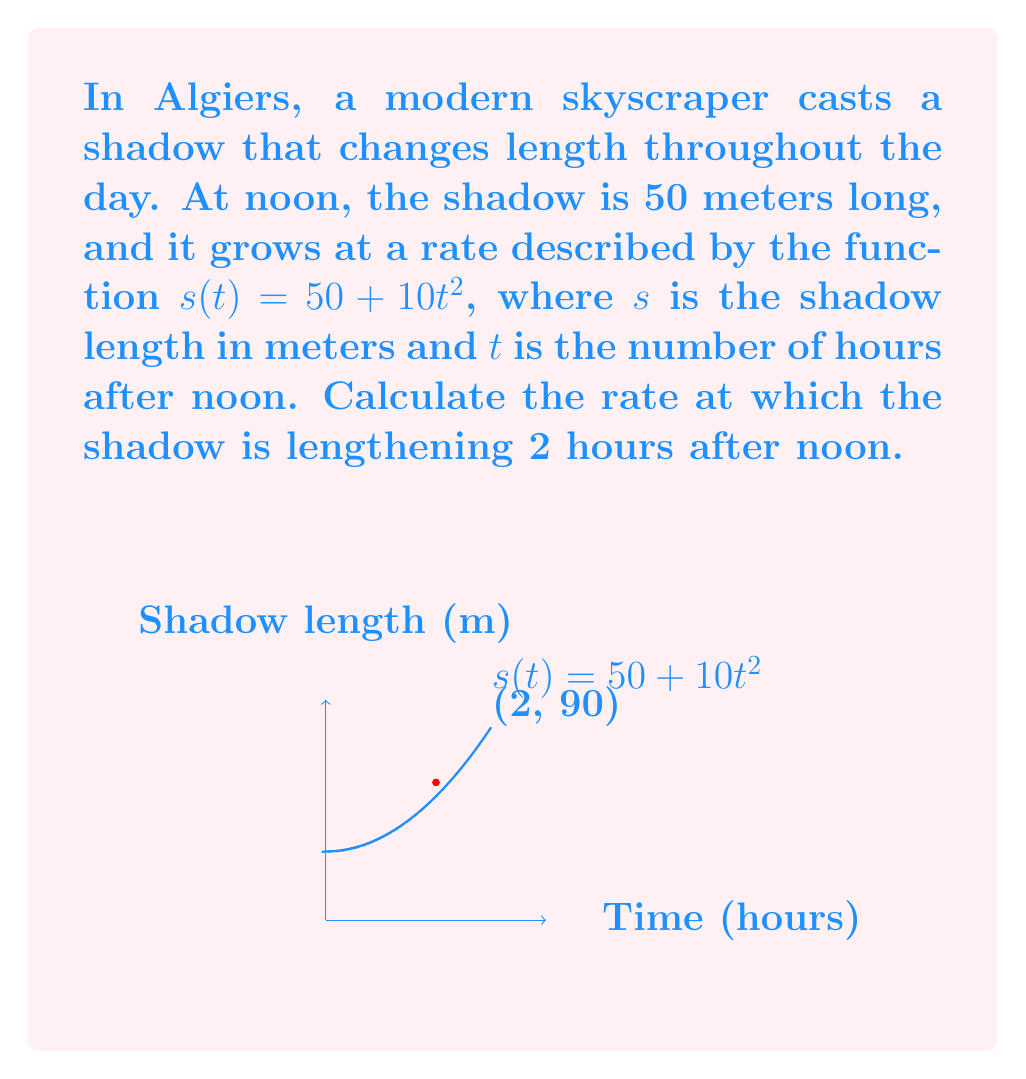Provide a solution to this math problem. To solve this problem, we need to find the derivative of the shadow length function and evaluate it at $t = 2$ hours. Let's break it down step-by-step:

1) The shadow length function is given as:
   $$s(t) = 50 + 10t^2$$

2) To find the rate of change, we need to differentiate $s(t)$ with respect to $t$:
   $$\frac{ds}{dt} = \frac{d}{dt}(50 + 10t^2)$$

3) Using the power rule of differentiation:
   $$\frac{ds}{dt} = 0 + 10 \cdot 2t = 20t$$

4) This derivative, $\frac{ds}{dt}$, represents the instantaneous rate of change of the shadow length.

5) To find the rate of change 2 hours after noon, we substitute $t = 2$ into our derivative:
   $$\frac{ds}{dt}\bigg|_{t=2} = 20(2) = 40$$

Therefore, 2 hours after noon, the shadow is lengthening at a rate of 40 meters per hour.
Answer: 40 meters per hour 